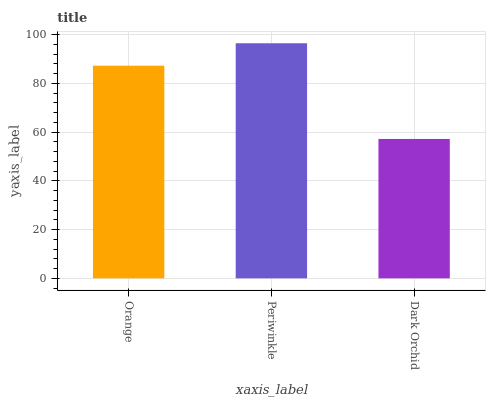Is Dark Orchid the minimum?
Answer yes or no. Yes. Is Periwinkle the maximum?
Answer yes or no. Yes. Is Periwinkle the minimum?
Answer yes or no. No. Is Dark Orchid the maximum?
Answer yes or no. No. Is Periwinkle greater than Dark Orchid?
Answer yes or no. Yes. Is Dark Orchid less than Periwinkle?
Answer yes or no. Yes. Is Dark Orchid greater than Periwinkle?
Answer yes or no. No. Is Periwinkle less than Dark Orchid?
Answer yes or no. No. Is Orange the high median?
Answer yes or no. Yes. Is Orange the low median?
Answer yes or no. Yes. Is Periwinkle the high median?
Answer yes or no. No. Is Dark Orchid the low median?
Answer yes or no. No. 